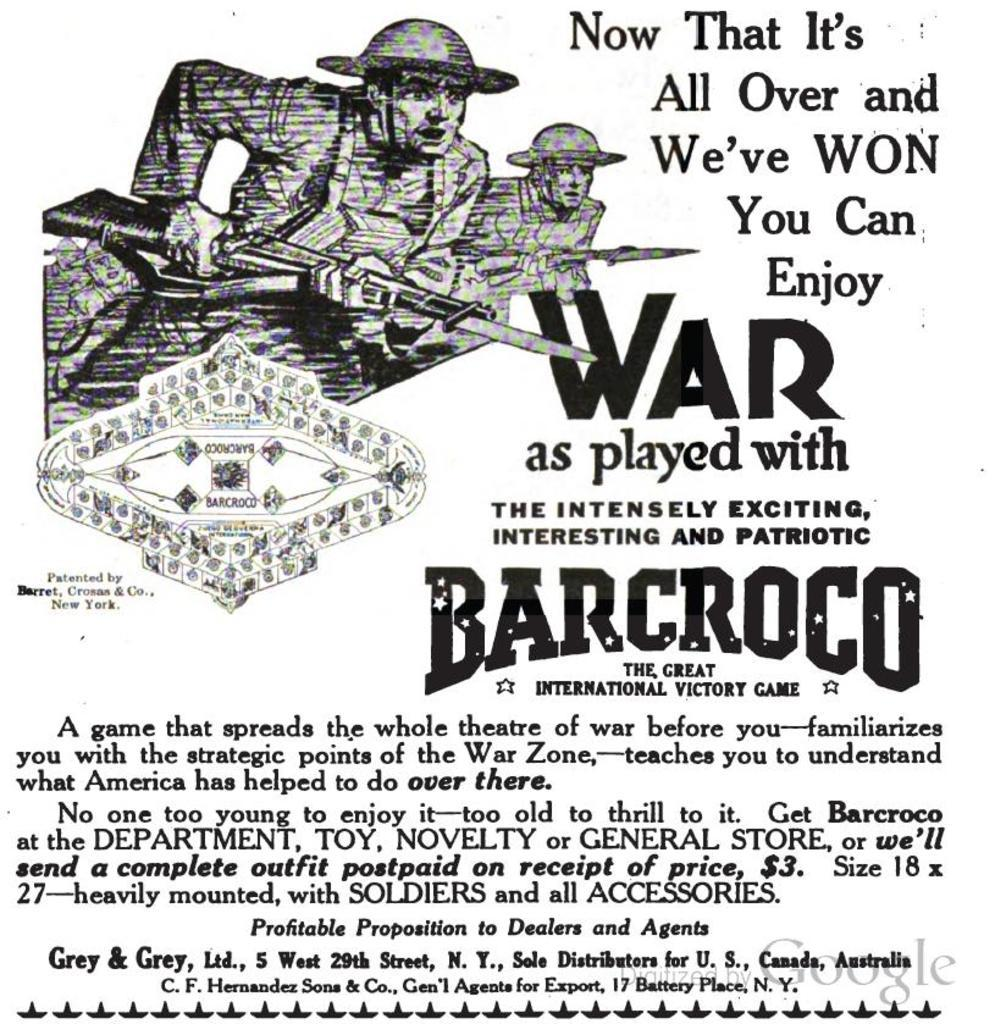<image>
Write a terse but informative summary of the picture. An old advertisement saying now it's over and we've won you can enjoy war. 